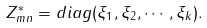<formula> <loc_0><loc_0><loc_500><loc_500>Z ^ { * } _ { m n } = d i a g ( \xi _ { 1 } , \xi _ { 2 } , \cdots , \xi _ { k } ) .</formula> 